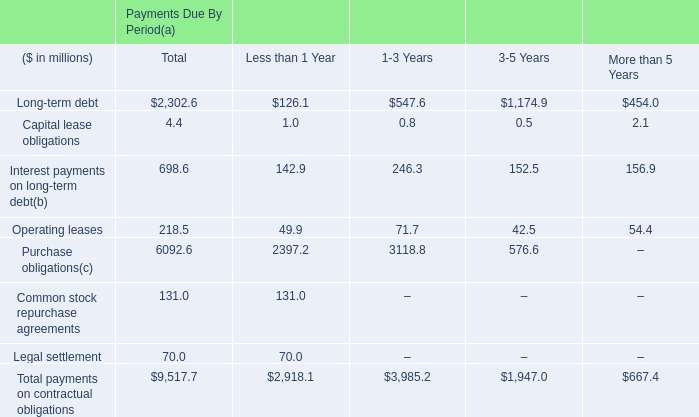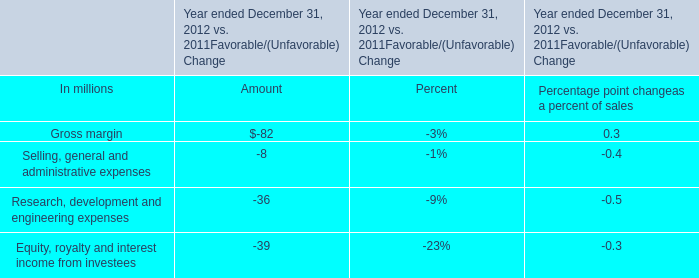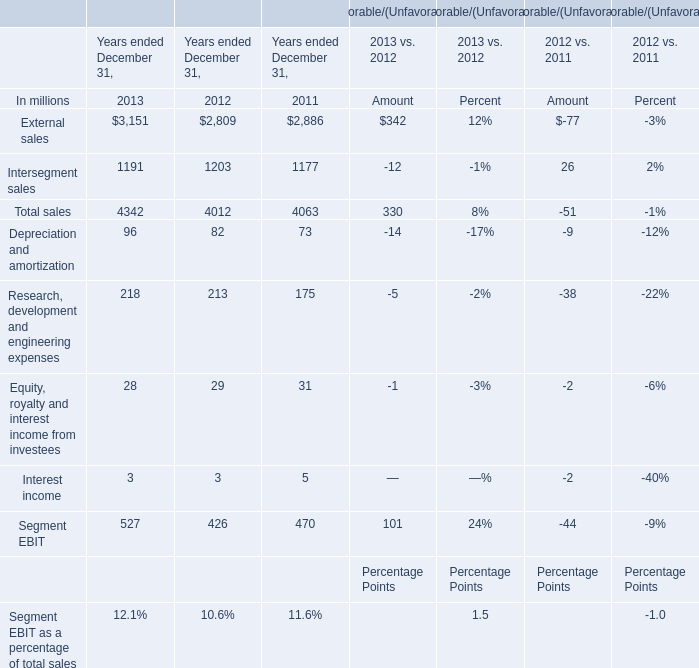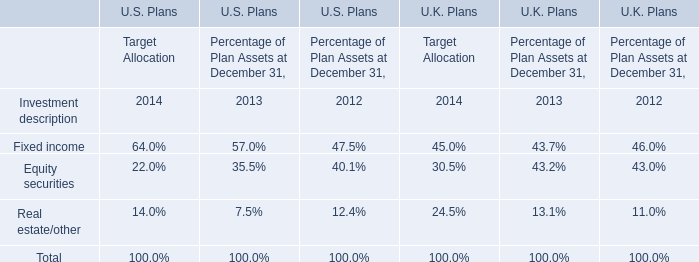What was the sum of Total sales without those sales smaller than 2000, in 2012? (in dollars in millions) 
Computations: (4012 - 1203)
Answer: 2809.0. 